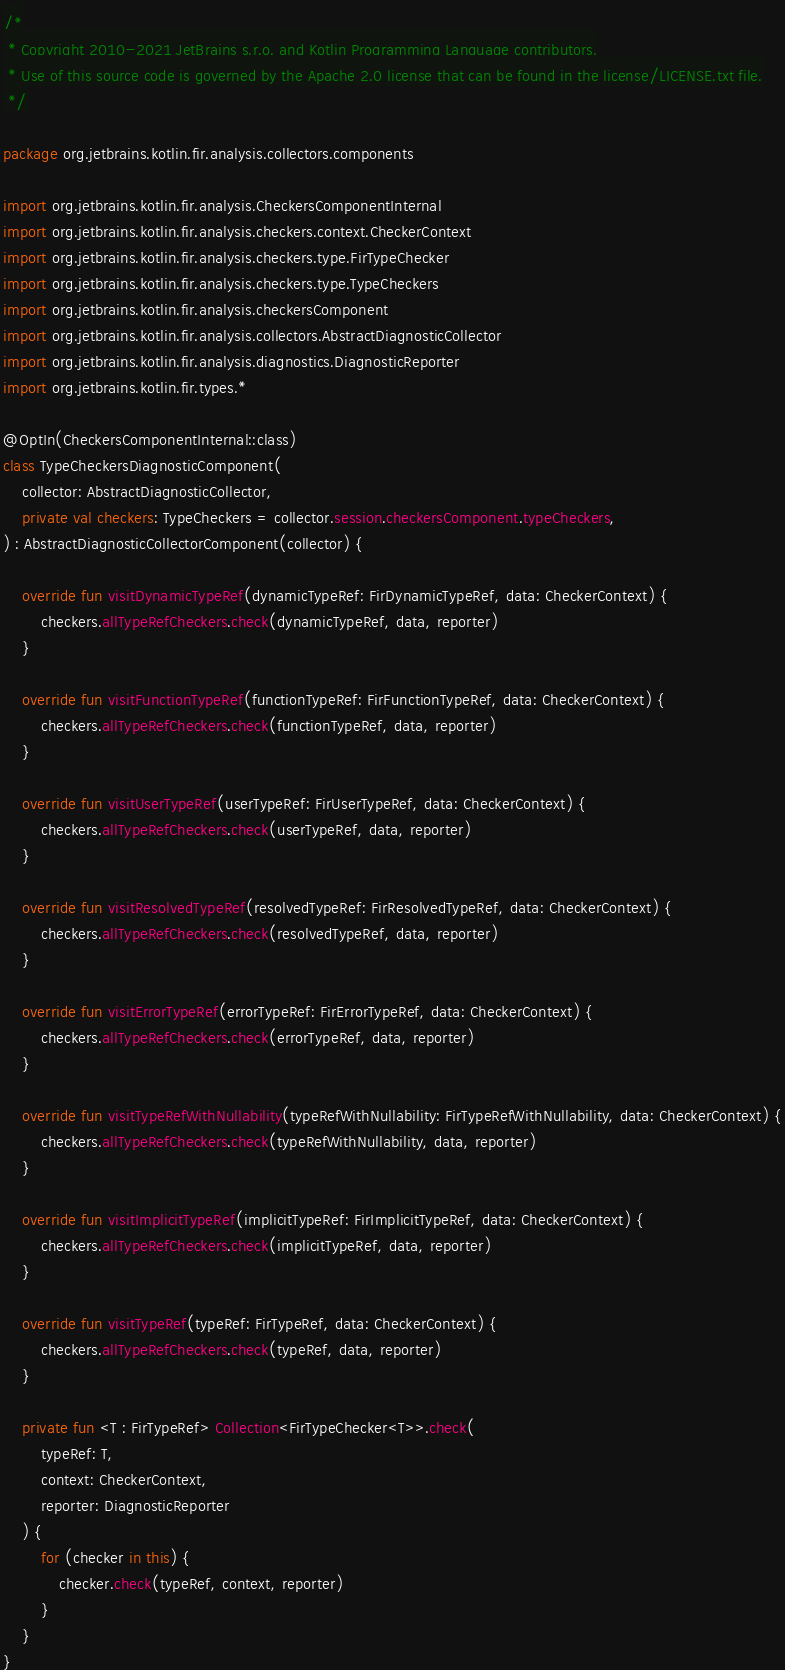Convert code to text. <code><loc_0><loc_0><loc_500><loc_500><_Kotlin_>/*
 * Copyright 2010-2021 JetBrains s.r.o. and Kotlin Programming Language contributors.
 * Use of this source code is governed by the Apache 2.0 license that can be found in the license/LICENSE.txt file.
 */

package org.jetbrains.kotlin.fir.analysis.collectors.components

import org.jetbrains.kotlin.fir.analysis.CheckersComponentInternal
import org.jetbrains.kotlin.fir.analysis.checkers.context.CheckerContext
import org.jetbrains.kotlin.fir.analysis.checkers.type.FirTypeChecker
import org.jetbrains.kotlin.fir.analysis.checkers.type.TypeCheckers
import org.jetbrains.kotlin.fir.analysis.checkersComponent
import org.jetbrains.kotlin.fir.analysis.collectors.AbstractDiagnosticCollector
import org.jetbrains.kotlin.fir.analysis.diagnostics.DiagnosticReporter
import org.jetbrains.kotlin.fir.types.*

@OptIn(CheckersComponentInternal::class)
class TypeCheckersDiagnosticComponent(
    collector: AbstractDiagnosticCollector,
    private val checkers: TypeCheckers = collector.session.checkersComponent.typeCheckers,
) : AbstractDiagnosticCollectorComponent(collector) {

    override fun visitDynamicTypeRef(dynamicTypeRef: FirDynamicTypeRef, data: CheckerContext) {
        checkers.allTypeRefCheckers.check(dynamicTypeRef, data, reporter)
    }

    override fun visitFunctionTypeRef(functionTypeRef: FirFunctionTypeRef, data: CheckerContext) {
        checkers.allTypeRefCheckers.check(functionTypeRef, data, reporter)
    }

    override fun visitUserTypeRef(userTypeRef: FirUserTypeRef, data: CheckerContext) {
        checkers.allTypeRefCheckers.check(userTypeRef, data, reporter)
    }

    override fun visitResolvedTypeRef(resolvedTypeRef: FirResolvedTypeRef, data: CheckerContext) {
        checkers.allTypeRefCheckers.check(resolvedTypeRef, data, reporter)
    }

    override fun visitErrorTypeRef(errorTypeRef: FirErrorTypeRef, data: CheckerContext) {
        checkers.allTypeRefCheckers.check(errorTypeRef, data, reporter)
    }

    override fun visitTypeRefWithNullability(typeRefWithNullability: FirTypeRefWithNullability, data: CheckerContext) {
        checkers.allTypeRefCheckers.check(typeRefWithNullability, data, reporter)
    }

    override fun visitImplicitTypeRef(implicitTypeRef: FirImplicitTypeRef, data: CheckerContext) {
        checkers.allTypeRefCheckers.check(implicitTypeRef, data, reporter)
    }

    override fun visitTypeRef(typeRef: FirTypeRef, data: CheckerContext) {
        checkers.allTypeRefCheckers.check(typeRef, data, reporter)
    }

    private fun <T : FirTypeRef> Collection<FirTypeChecker<T>>.check(
        typeRef: T,
        context: CheckerContext,
        reporter: DiagnosticReporter
    ) {
        for (checker in this) {
            checker.check(typeRef, context, reporter)
        }
    }
}
</code> 